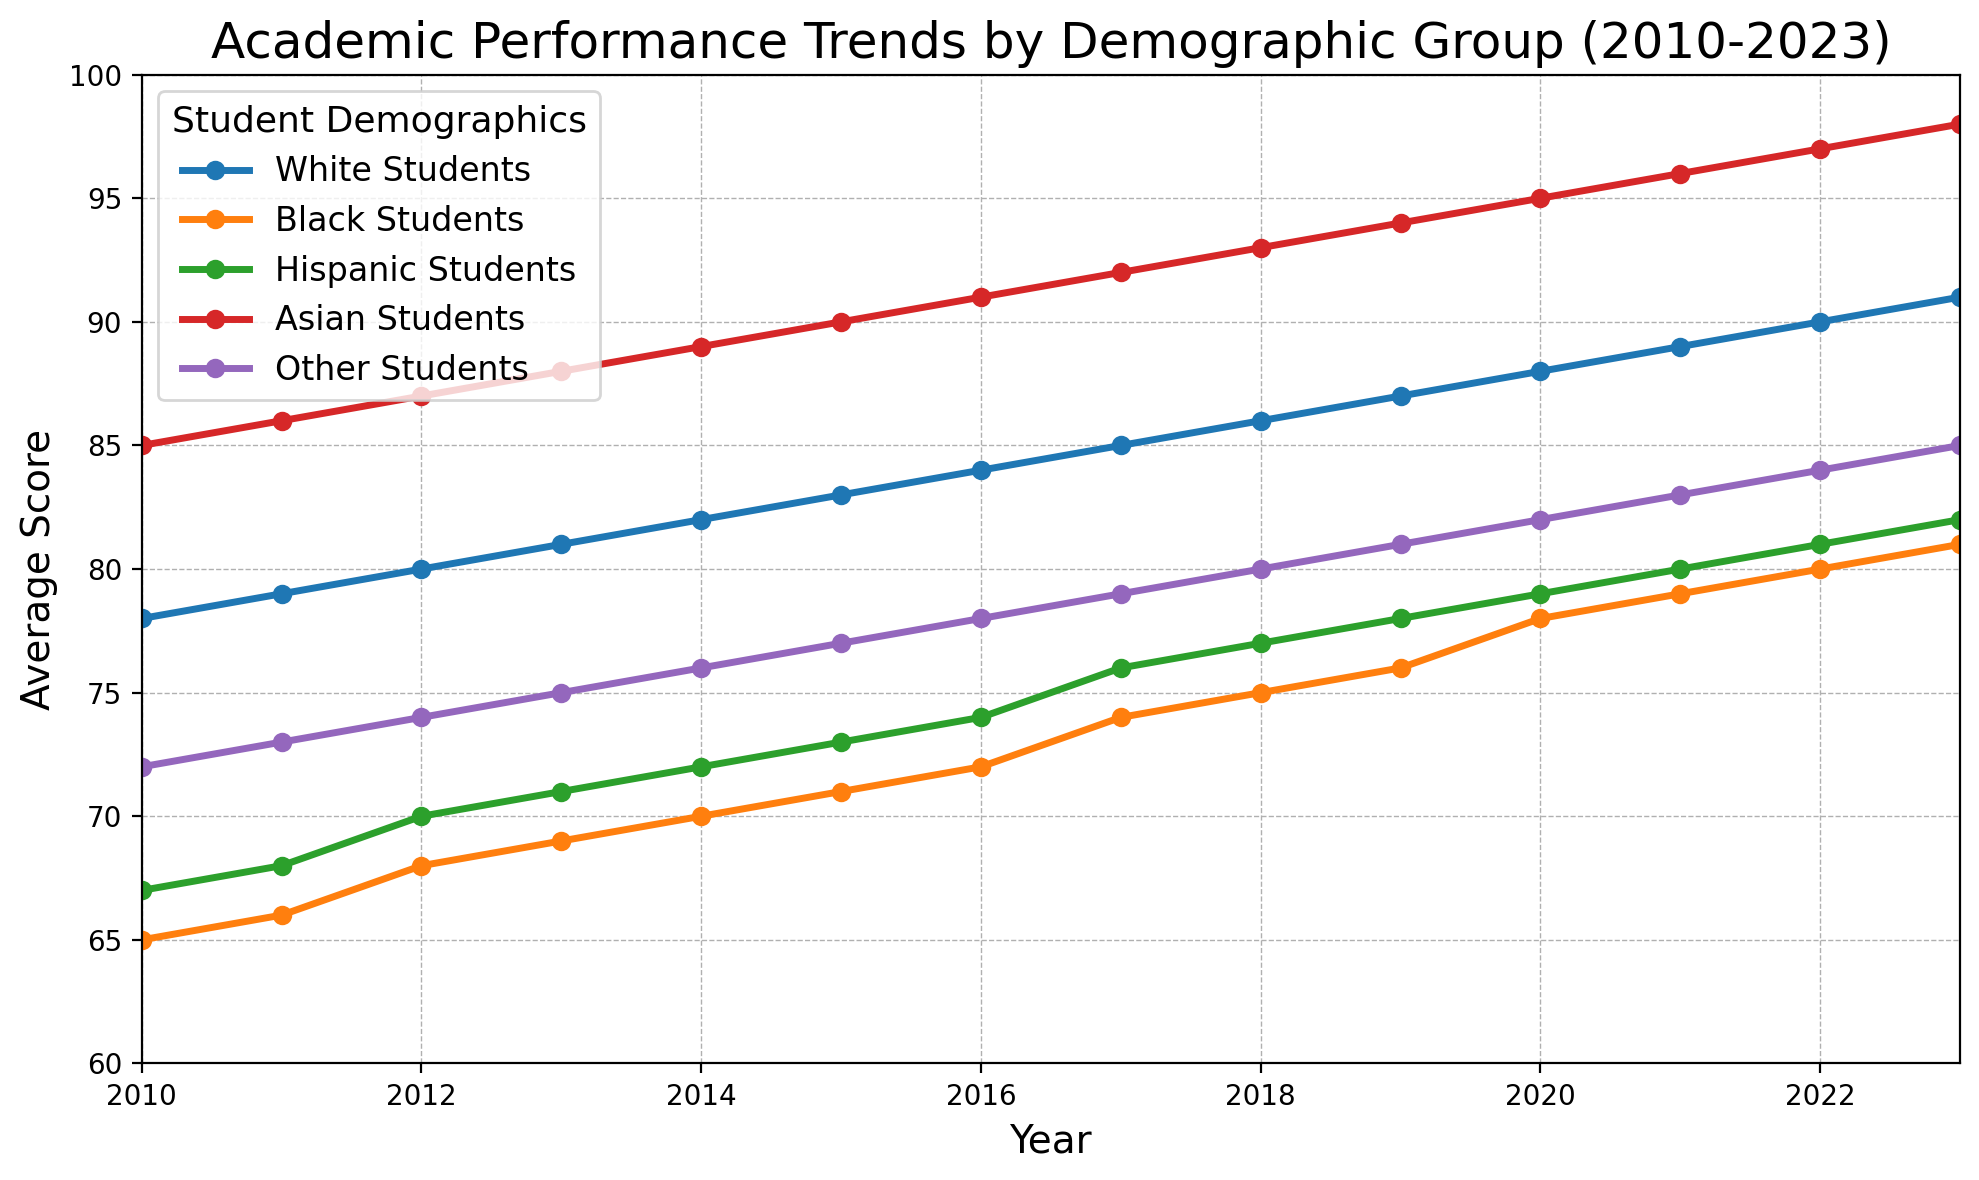Which demographic group has the highest average score in 2023? By looking at the figure, you can see that the line representing Asian Students is the highest in 2023. Therefore, Asian Students have the highest average score in 2023.
Answer: Asian Students How much did the average score for Black Students improve from 2010 to 2023? The average score for Black Students in 2010 is 65 and in 2023 it is 81. The difference is 81 - 65 = 16.
Answer: 16 Between which years did Hispanic Students show the greatest increase in their average score? By comparing year-over-year increases, the largest increase for Hispanic Students appears between any consecutive years in the figure. Here, between 2016 and 2017, the score increased from 74 to 76, a jump of 2 points.
Answer: 2016 to 2017 What is the difference in average scores between Hispanic Students and Asian Students in 2023? Hispanic Students have an average score of 82 in 2023, while Asian Students have an average score of 98. The difference is 98 - 82 = 16.
Answer: 16 Which demographic group showed a consistent increase every year from 2010 to 2023? By inspecting the lines, you can see that all the demographic groups show a consistent increase year over year from 2010 to 2023.
Answer: All demographic groups In which year did White Students surpass an average score of 85? By tracing the line for White Students, it surpasses 85 between 2016 and 2017. Therefore, it surpassed 85 in 2017.
Answer: 2017 What is the overall trend in average scores for all demographic groups from 2010 to 2023? All lines representing different demographic groups show a continuous upward trend from 2010 to 2023.
Answer: Upward trend How does the average score of Other Students in 2015 compare to the average score of White Students in 2011? The figure shows that Other Students had a score of 77 in 2015, while White Students had a score of 79 in 2011. Therefore, Other Students' score in 2015 is lower by 2 points.
Answer: Lower by 2 points What is the combined increase in the average scores of Black Students and Hispanic Students from 2010 to 2023? The increase for Black Students from 2010 to 2023 is 81 - 65 = 16. The increase for Hispanic Students from 2010 to 2023 is 82 - 67 = 15. The combined increase is 16 + 15 = 31.
Answer: 31 